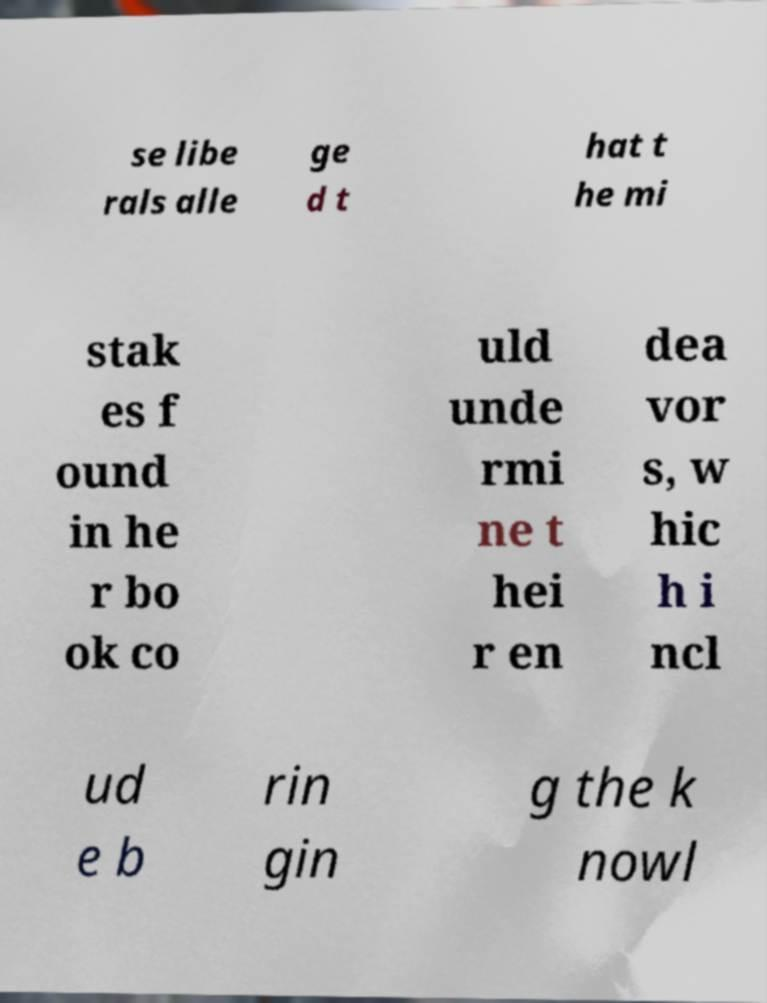Can you read and provide the text displayed in the image?This photo seems to have some interesting text. Can you extract and type it out for me? se libe rals alle ge d t hat t he mi stak es f ound in he r bo ok co uld unde rmi ne t hei r en dea vor s, w hic h i ncl ud e b rin gin g the k nowl 